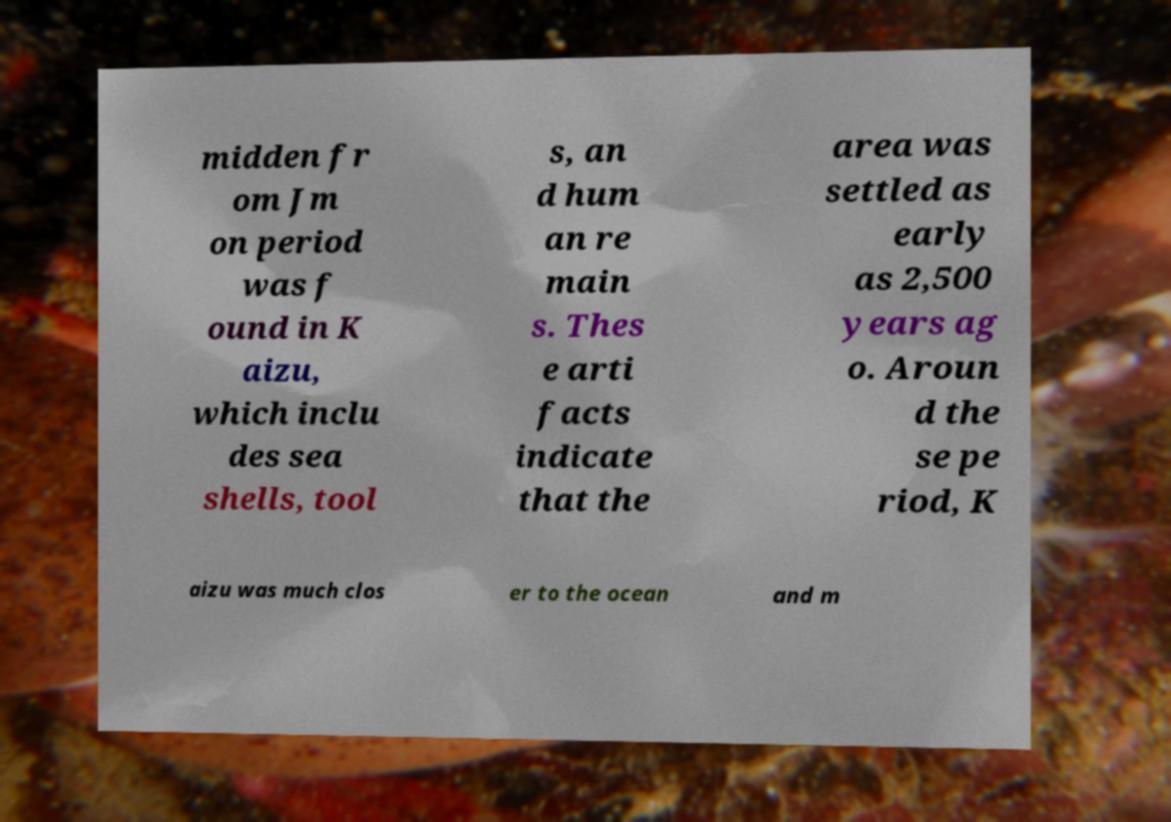What messages or text are displayed in this image? I need them in a readable, typed format. midden fr om Jm on period was f ound in K aizu, which inclu des sea shells, tool s, an d hum an re main s. Thes e arti facts indicate that the area was settled as early as 2,500 years ag o. Aroun d the se pe riod, K aizu was much clos er to the ocean and m 